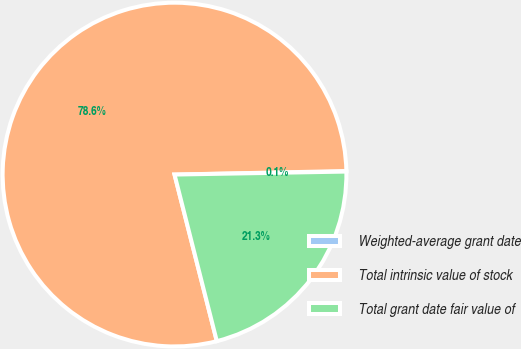<chart> <loc_0><loc_0><loc_500><loc_500><pie_chart><fcel>Weighted-average grant date<fcel>Total intrinsic value of stock<fcel>Total grant date fair value of<nl><fcel>0.05%<fcel>78.63%<fcel>21.32%<nl></chart> 